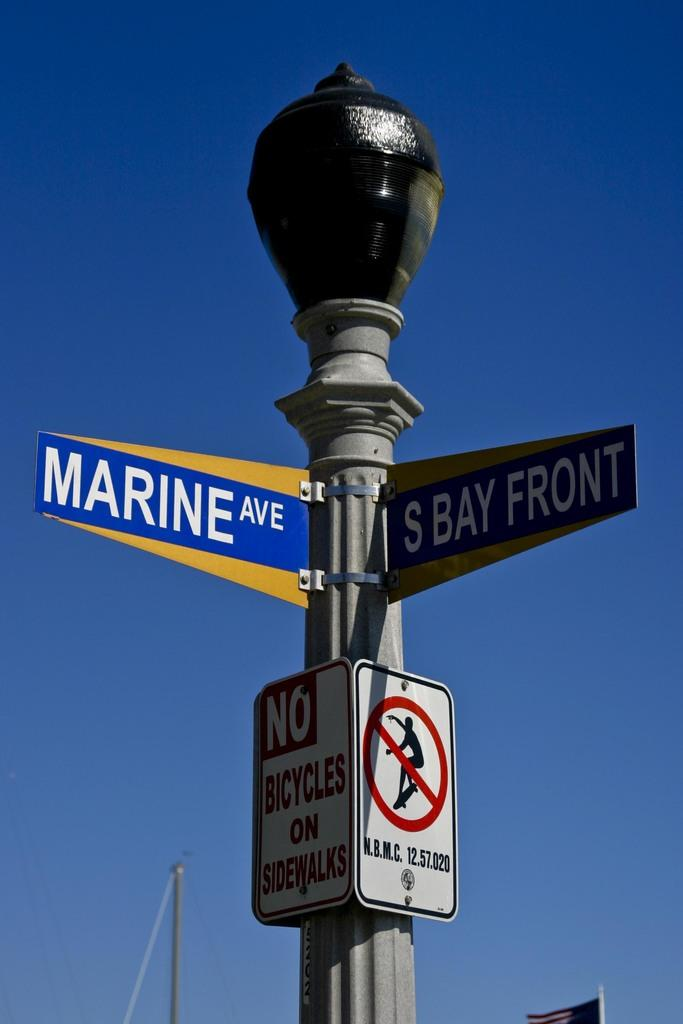Provide a one-sentence caption for the provided image. Two street signs designate the intersection of Marine Ave and S Bay Front. 